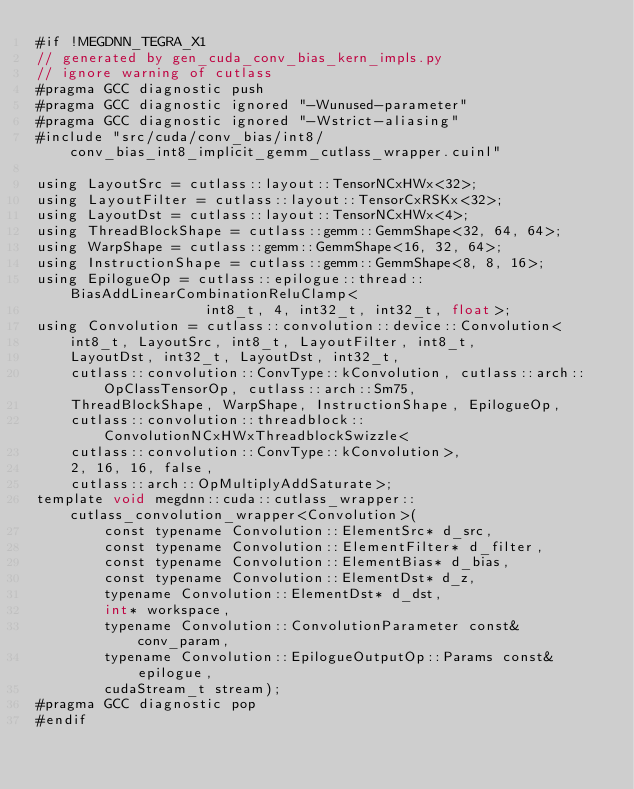<code> <loc_0><loc_0><loc_500><loc_500><_Cuda_>#if !MEGDNN_TEGRA_X1
// generated by gen_cuda_conv_bias_kern_impls.py
// ignore warning of cutlass
#pragma GCC diagnostic push
#pragma GCC diagnostic ignored "-Wunused-parameter"
#pragma GCC diagnostic ignored "-Wstrict-aliasing"
#include "src/cuda/conv_bias/int8/conv_bias_int8_implicit_gemm_cutlass_wrapper.cuinl"

using LayoutSrc = cutlass::layout::TensorNCxHWx<32>;
using LayoutFilter = cutlass::layout::TensorCxRSKx<32>;
using LayoutDst = cutlass::layout::TensorNCxHWx<4>;
using ThreadBlockShape = cutlass::gemm::GemmShape<32, 64, 64>;
using WarpShape = cutlass::gemm::GemmShape<16, 32, 64>;
using InstructionShape = cutlass::gemm::GemmShape<8, 8, 16>;
using EpilogueOp = cutlass::epilogue::thread::BiasAddLinearCombinationReluClamp<
                    int8_t, 4, int32_t, int32_t, float>;
using Convolution = cutlass::convolution::device::Convolution<
    int8_t, LayoutSrc, int8_t, LayoutFilter, int8_t, 
    LayoutDst, int32_t, LayoutDst, int32_t, 
    cutlass::convolution::ConvType::kConvolution, cutlass::arch::OpClassTensorOp, cutlass::arch::Sm75, 
    ThreadBlockShape, WarpShape, InstructionShape, EpilogueOp, 
    cutlass::convolution::threadblock::ConvolutionNCxHWxThreadblockSwizzle<
    cutlass::convolution::ConvType::kConvolution>, 
    2, 16, 16, false, 
    cutlass::arch::OpMultiplyAddSaturate>;
template void megdnn::cuda::cutlass_wrapper::cutlass_convolution_wrapper<Convolution>(
        const typename Convolution::ElementSrc* d_src, 
        const typename Convolution::ElementFilter* d_filter, 
        const typename Convolution::ElementBias* d_bias, 
        const typename Convolution::ElementDst* d_z, 
        typename Convolution::ElementDst* d_dst, 
        int* workspace, 
        typename Convolution::ConvolutionParameter const& conv_param, 
        typename Convolution::EpilogueOutputOp::Params const& epilogue, 
        cudaStream_t stream);
#pragma GCC diagnostic pop
#endif
</code> 